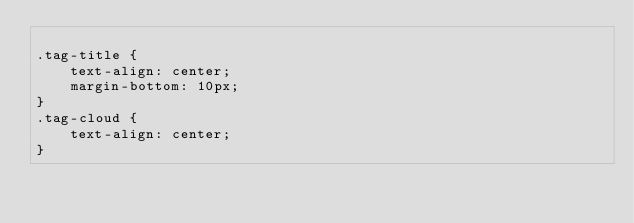Convert code to text. <code><loc_0><loc_0><loc_500><loc_500><_CSS_>
.tag-title {
    text-align: center;
    margin-bottom: 10px;
}
.tag-cloud {
    text-align: center;
}</code> 